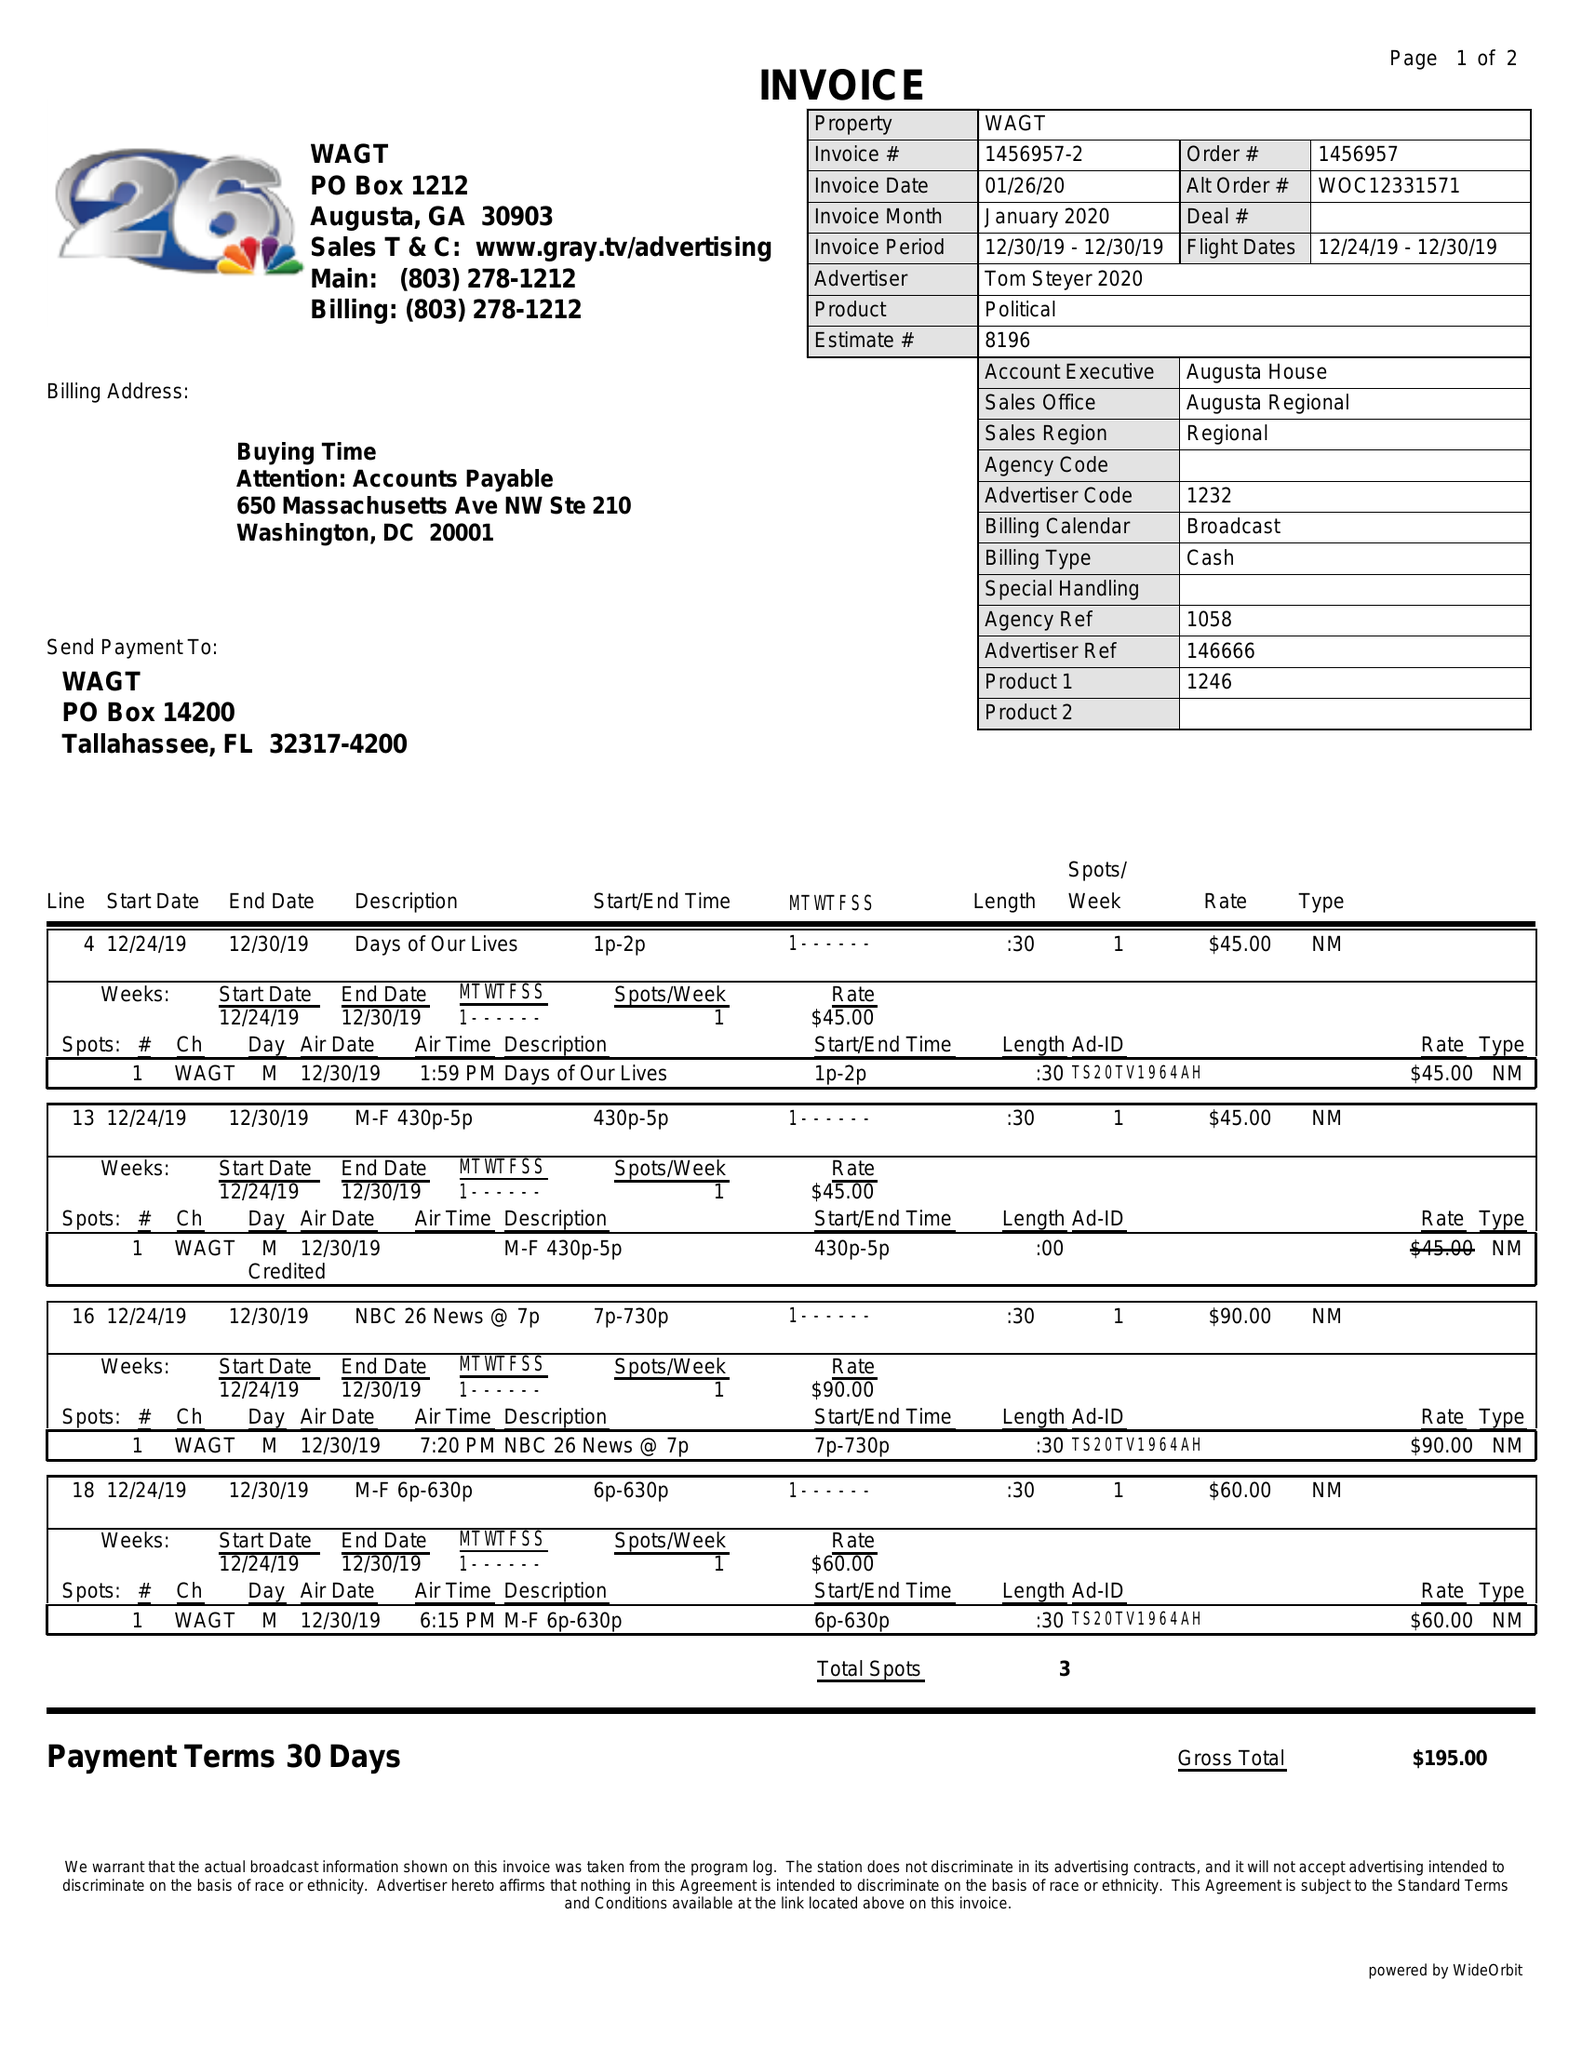What is the value for the gross_amount?
Answer the question using a single word or phrase. 195.00 